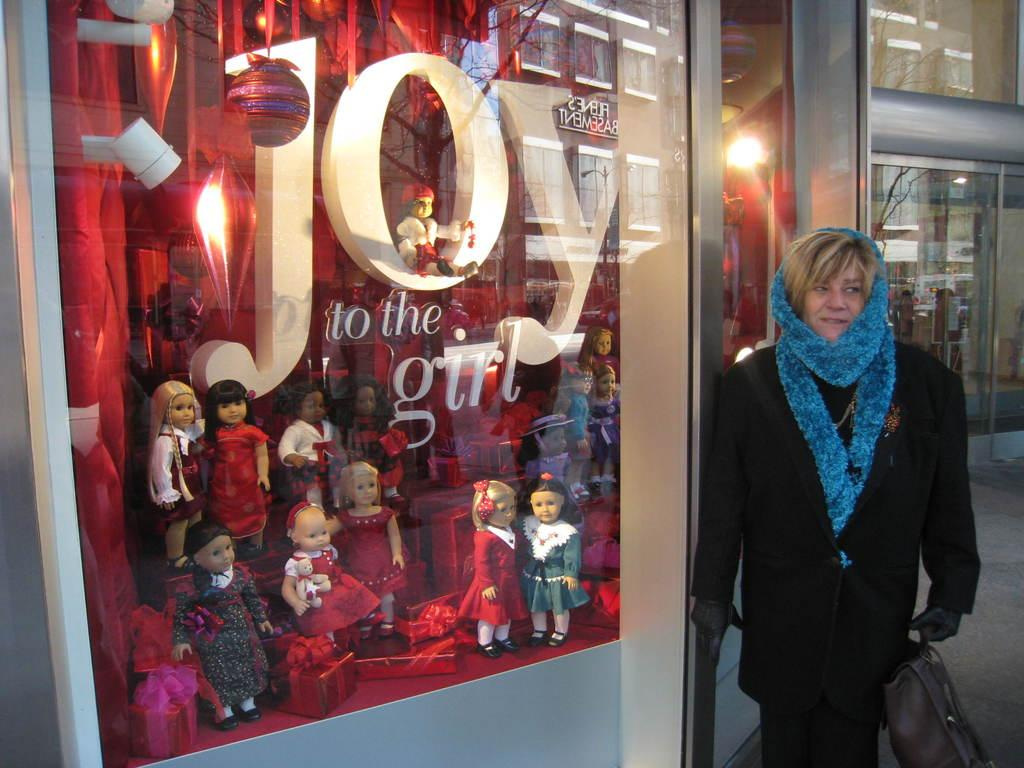What type of store is depicted in the image? The image appears to depict a toy store. Can you describe the person in the foreground? There is a lady standing in the foreground. What is the lady holding in her hand? The lady is holding a bag in her hand. What can be seen in the background of the image? There is a building and light visible in the background. What type of canvas is the lady painting in the image? There is no canvas or painting activity present in the image. How does the faucet in the image help with the toy store's operations? There is no faucet present in the image. 